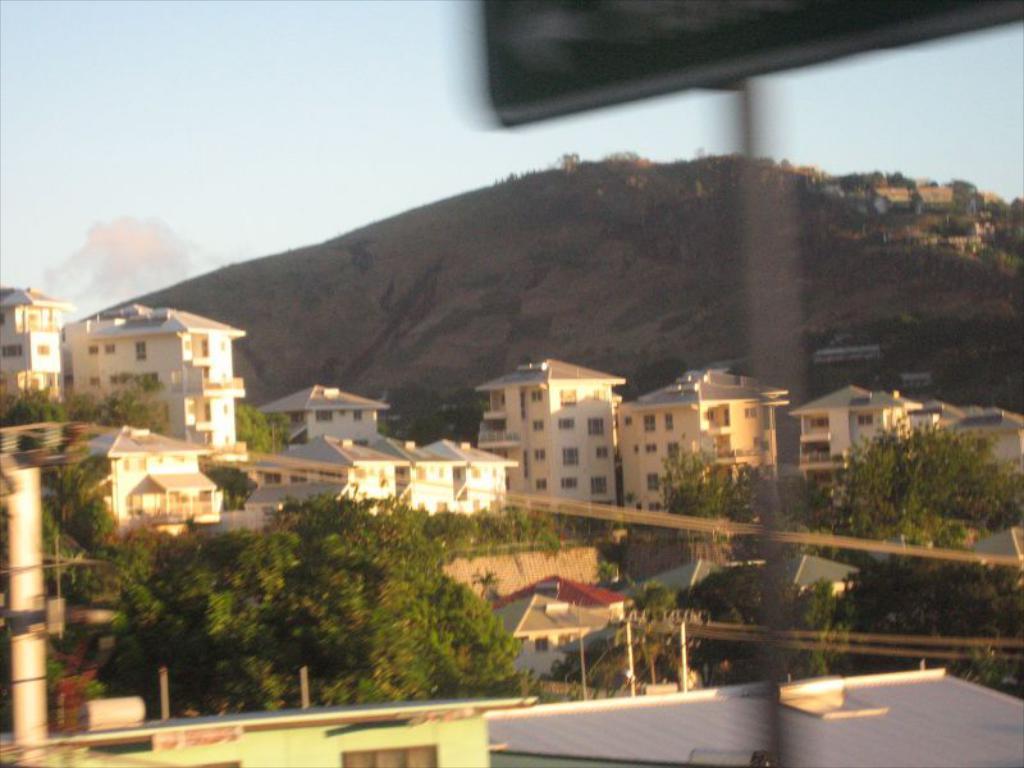Describe this image in one or two sentences. In the foreground, I can see trees, buildings, windows, poles and wires. In the background, I can see mountains and the sky. This image taken, maybe during a day. 